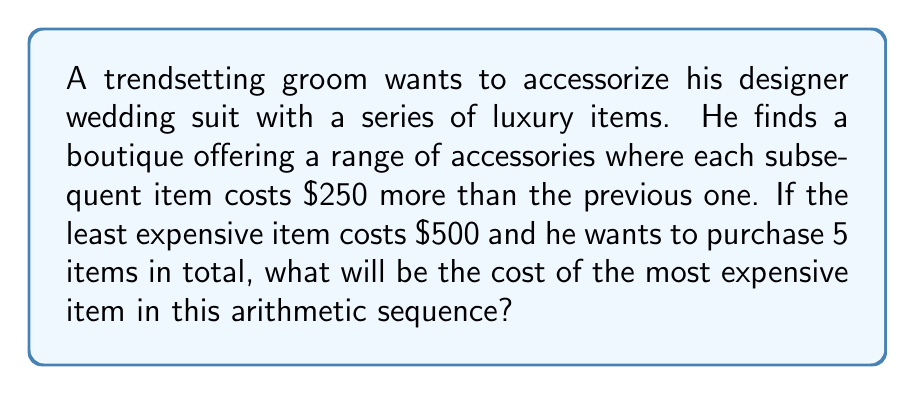Can you answer this question? Let's approach this step-by-step:

1) We're dealing with an arithmetic sequence where:
   - The first term, $a_1 = 500$
   - The common difference, $d = 250$
   - We need to find the 5th term, $a_5$

2) The formula for the nth term of an arithmetic sequence is:
   $a_n = a_1 + (n-1)d$

3) In this case, we're looking for $a_5$, so:
   $a_5 = a_1 + (5-1)d$

4) Let's substitute the values:
   $a_5 = 500 + (4)(250)$

5) Simplify:
   $a_5 = 500 + 1000$
   $a_5 = 1500$

Therefore, the most expensive item (the 5th term in the sequence) will cost $1500.
Answer: $1500 